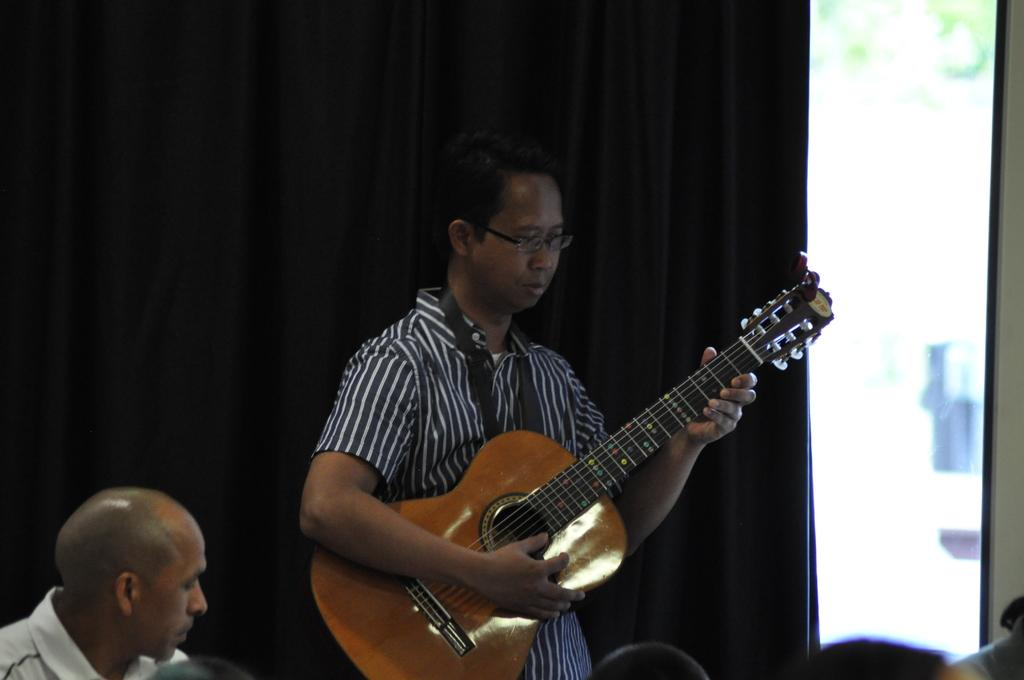How many people are in the image? There are two men in the image. What is one of the men doing in the image? One man is standing. What is the standing man holding in the image? The standing man is holding a guitar. What accessory is the standing man wearing in the image? The standing man is wearing glasses (specs). What type of railway is visible in the image? There is no railway present in the image. What kind of pot is being used for the distribution of goods in the image? There is no pot or distribution of goods depicted in the image. 